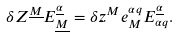<formula> <loc_0><loc_0><loc_500><loc_500>\delta Z ^ { \underline { M } } E _ { \underline { M } } ^ { \underline { \alpha } } = \delta z ^ { M } e _ { M } ^ { \alpha q } E _ { \alpha q } ^ { \underline { \alpha } } .</formula> 